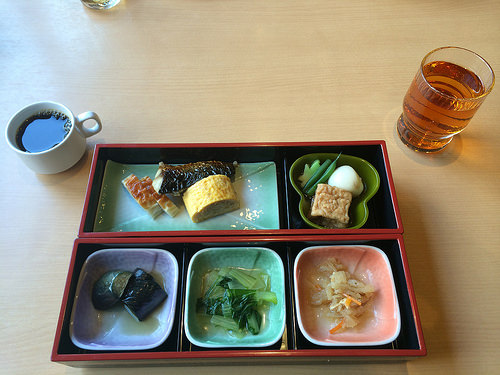<image>
Is the coffee next to the food plate? Yes. The coffee is positioned adjacent to the food plate, located nearby in the same general area. 